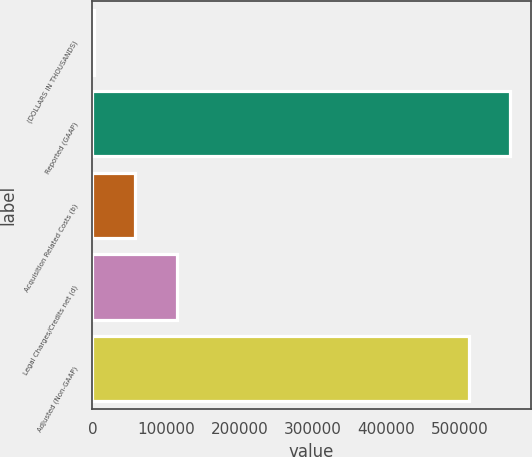<chart> <loc_0><loc_0><loc_500><loc_500><bar_chart><fcel>(DOLLARS IN THOUSANDS)<fcel>Reported (GAAP)<fcel>Acquisition Related Costs (b)<fcel>Legal Charges/Credits net (d)<fcel>Adjusted (Non-GAAP)<nl><fcel>2016<fcel>568205<fcel>58436.8<fcel>114858<fcel>511784<nl></chart> 